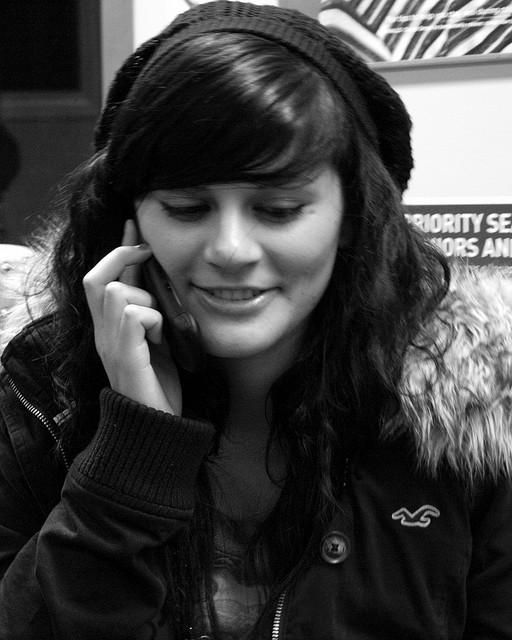What is the woman doing?
Be succinct. Talking on phone. Is the girl wearing a hat?
Answer briefly. Yes. What brand is the girl's coat?
Concise answer only. American eagle. Is she holding a smartphone?
Keep it brief. Yes. What color is the nail polish?
Give a very brief answer. Red. Is she standing inside?
Concise answer only. Yes. IS the woman wearing glasses?
Be succinct. No. Is this a male or female child?
Write a very short answer. Female. What is the female talking on?
Quick response, please. Cell phone. Where are the eyeglasses?
Give a very brief answer. Nowhere. Does the girl have 20/20 vision?
Answer briefly. Yes. Is that her real hair?
Write a very short answer. Yes. Does the girl have freckles?
Be succinct. No. What is on the woman's eyes?
Quick response, please. Nothing. 